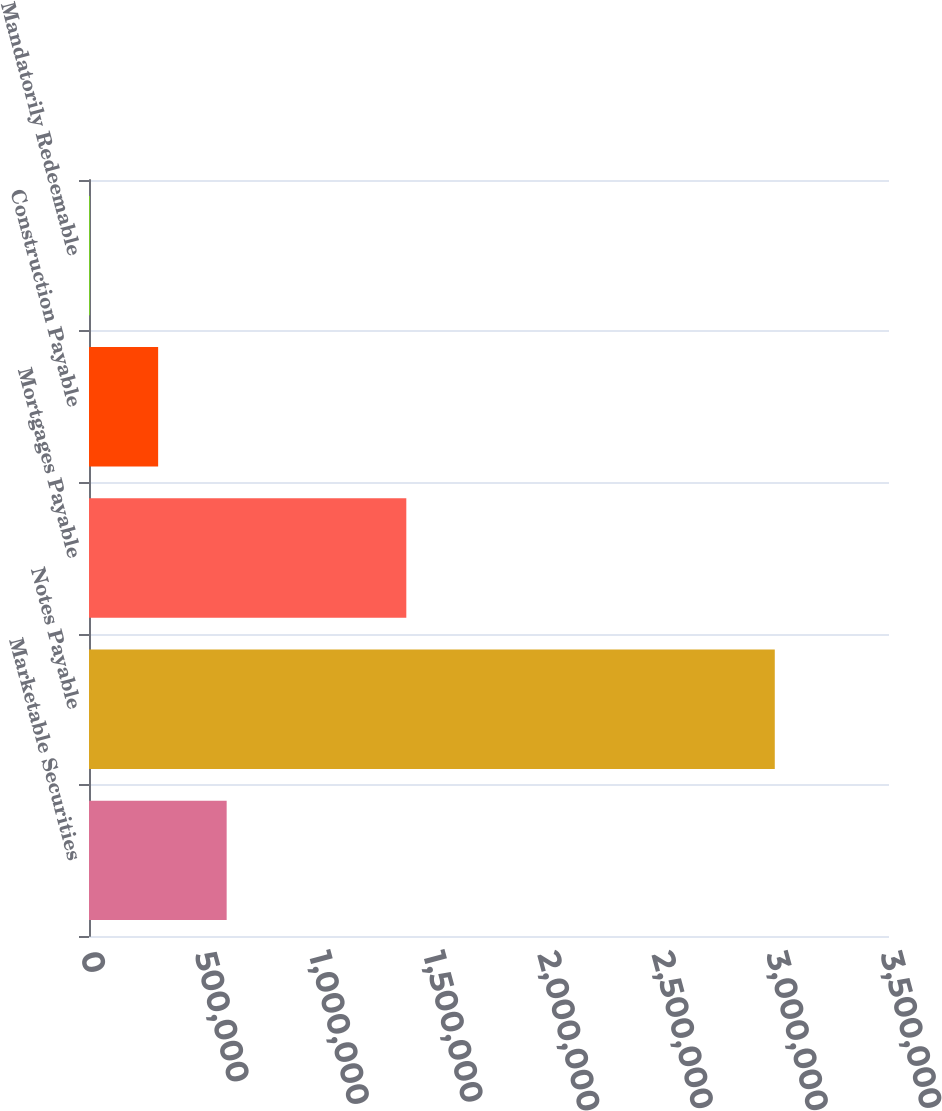<chart> <loc_0><loc_0><loc_500><loc_500><bar_chart><fcel>Marketable Securities<fcel>Notes Payable<fcel>Mortgages Payable<fcel>Construction Payable<fcel>Mandatorily Redeemable<nl><fcel>602275<fcel>3.0003e+06<fcel>1.38826e+06<fcel>302522<fcel>2768<nl></chart> 